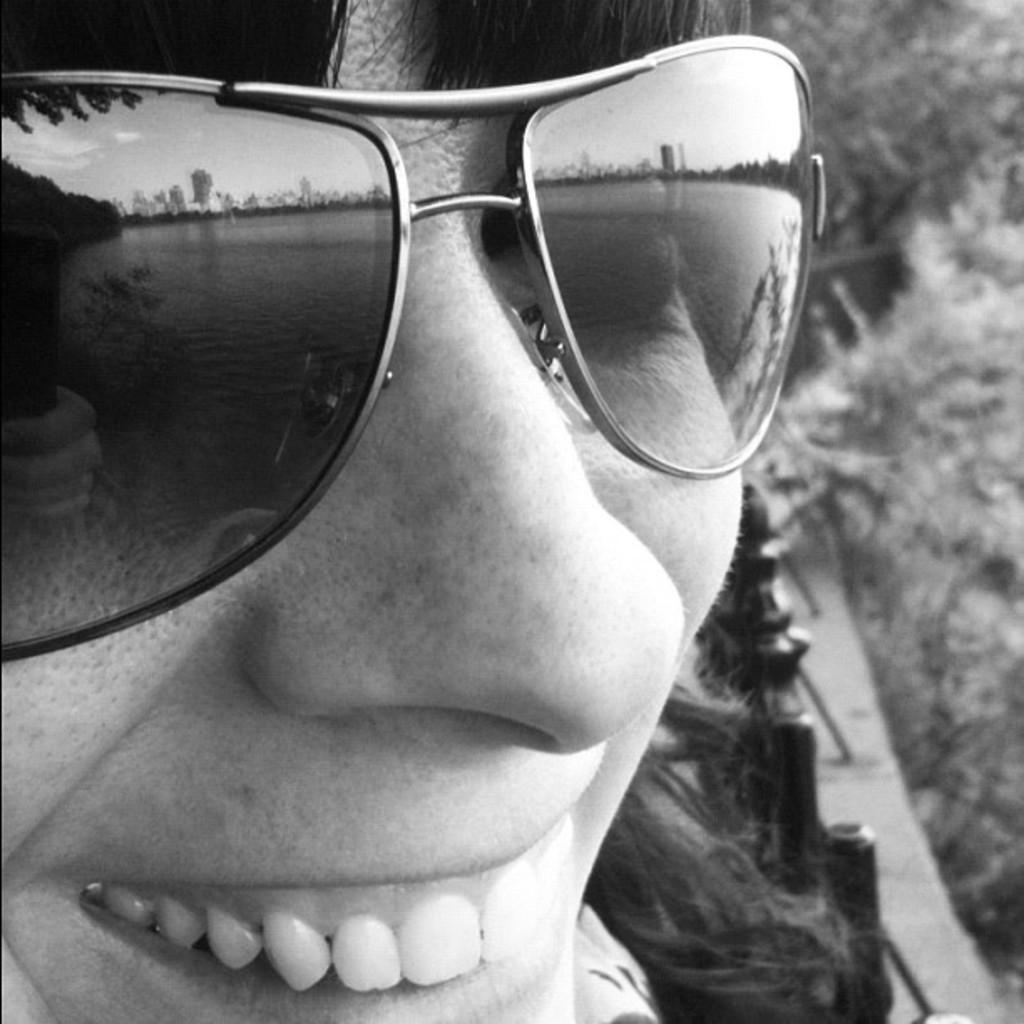Describe this image in one or two sentences. In the foreground of this black and white image, there is a person´s face wearing spectacles and in the background, it seems like trees. In the reflection of spectacles, we can see water, trees and the sky. 